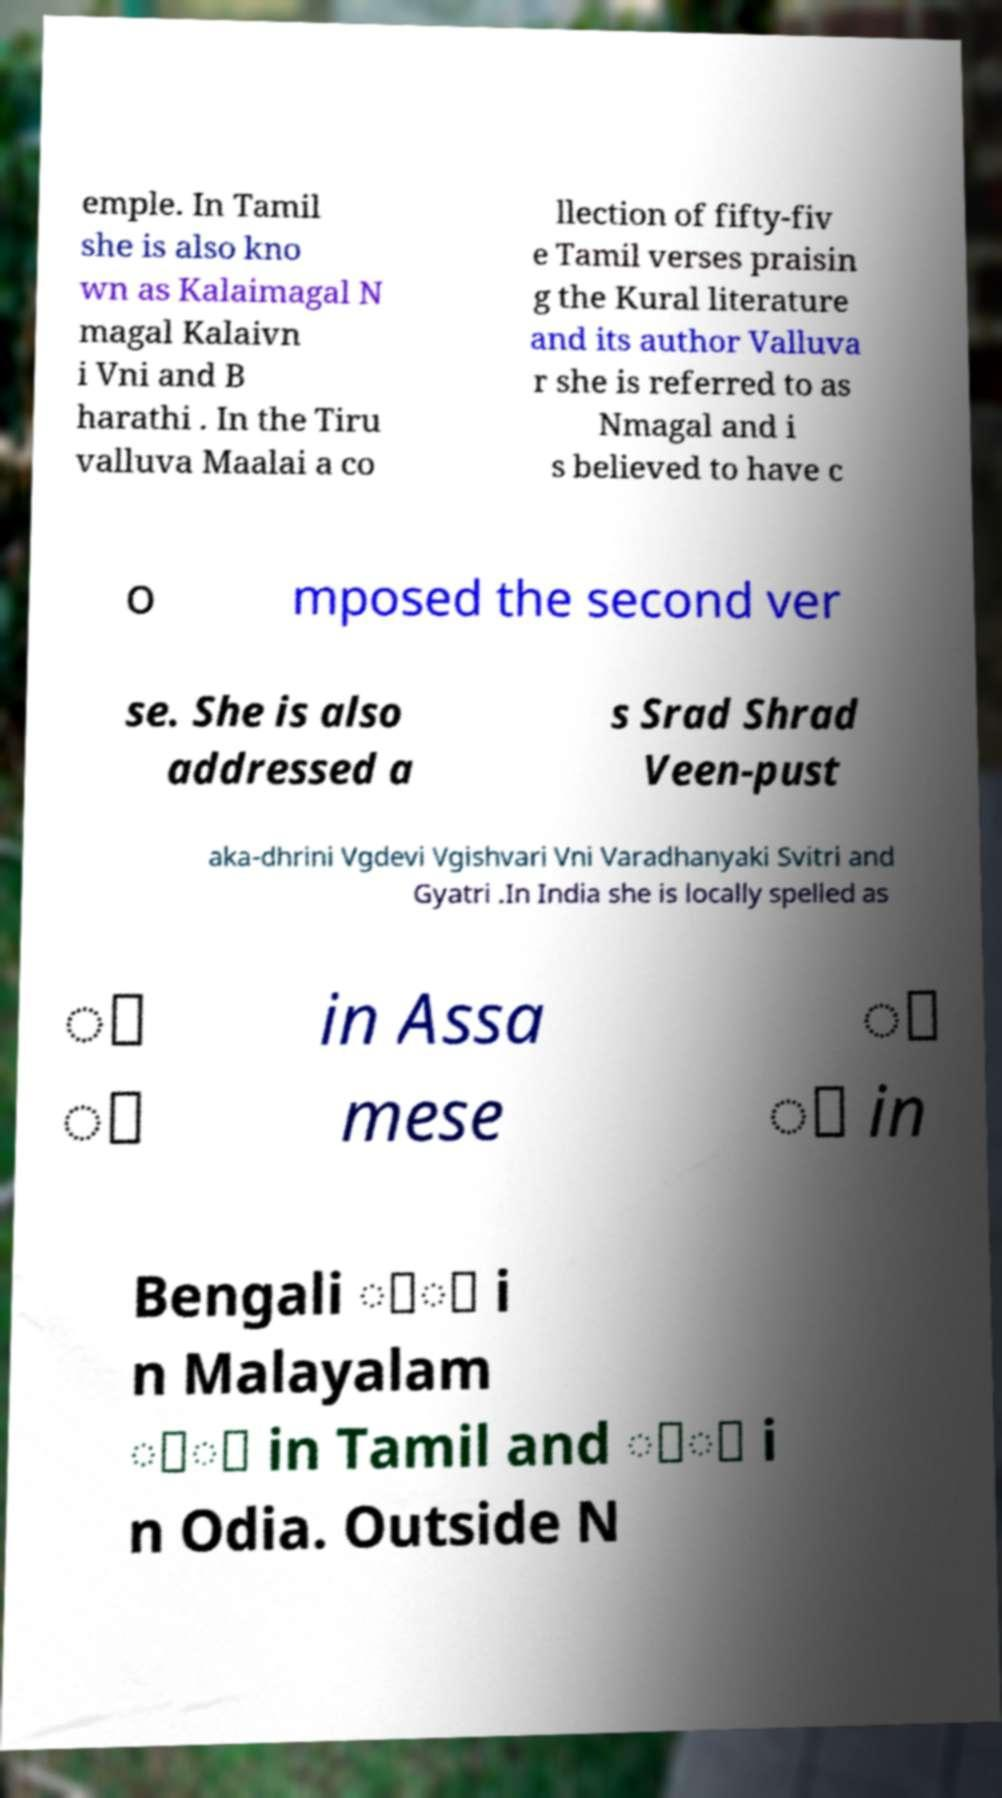Can you accurately transcribe the text from the provided image for me? emple. In Tamil she is also kno wn as Kalaimagal N magal Kalaivn i Vni and B harathi . In the Tiru valluva Maalai a co llection of fifty-fiv e Tamil verses praisin g the Kural literature and its author Valluva r she is referred to as Nmagal and i s believed to have c o mposed the second ver se. She is also addressed a s Srad Shrad Veen-pust aka-dhrini Vgdevi Vgishvari Vni Varadhanyaki Svitri and Gyatri .In India she is locally spelled as ্ ী in Assa mese ্ ী in Bengali ്ി i n Malayalam ்ி in Tamil and ୍ୀ i n Odia. Outside N 